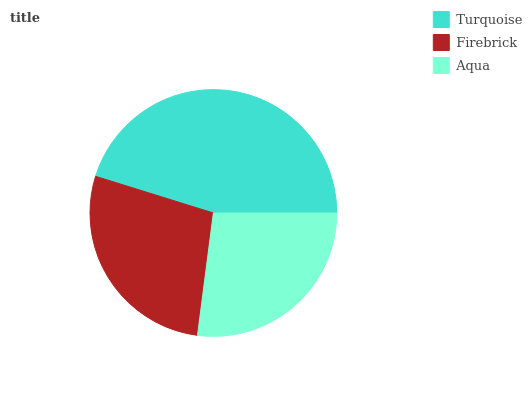Is Aqua the minimum?
Answer yes or no. Yes. Is Turquoise the maximum?
Answer yes or no. Yes. Is Firebrick the minimum?
Answer yes or no. No. Is Firebrick the maximum?
Answer yes or no. No. Is Turquoise greater than Firebrick?
Answer yes or no. Yes. Is Firebrick less than Turquoise?
Answer yes or no. Yes. Is Firebrick greater than Turquoise?
Answer yes or no. No. Is Turquoise less than Firebrick?
Answer yes or no. No. Is Firebrick the high median?
Answer yes or no. Yes. Is Firebrick the low median?
Answer yes or no. Yes. Is Aqua the high median?
Answer yes or no. No. Is Aqua the low median?
Answer yes or no. No. 